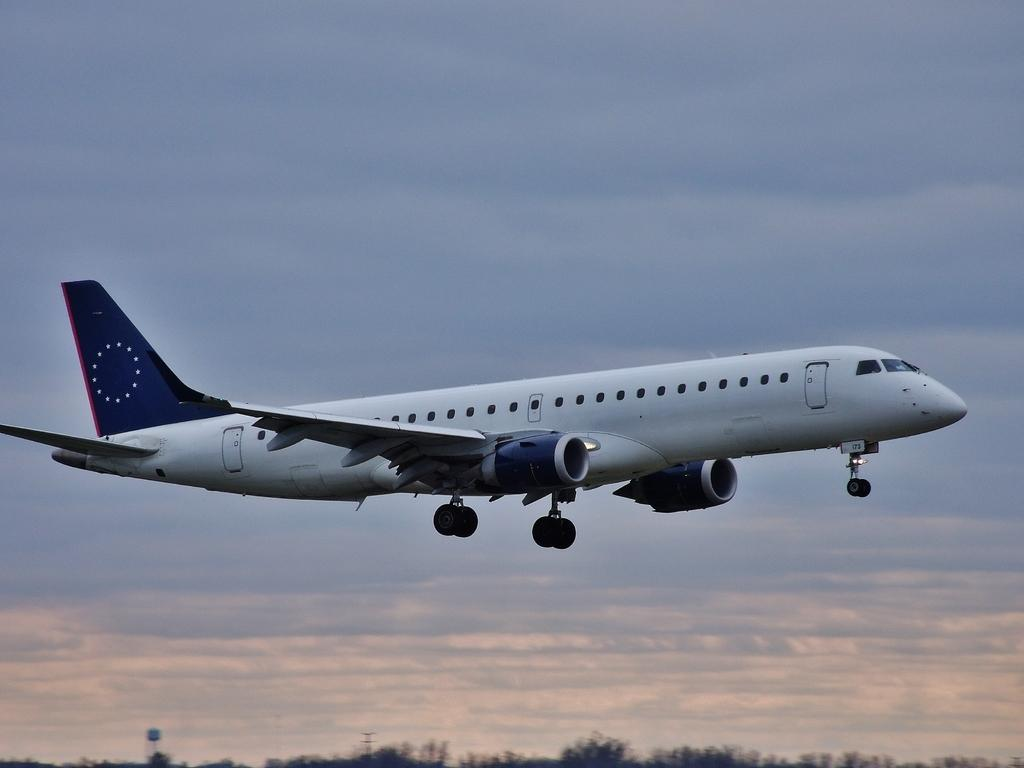What is the main subject of the image? The main subject of the image is an aeroplane. What is the aeroplane doing in the image? The aeroplane is flying in the sky. What can be seen at the bottom of the image? There are trees and poles at the bottom of the image. What type of tool does the carpenter use to communicate with the aeroplane in the image? There is no carpenter or tool present in the image, and the aeroplane is not communicating with anyone. What is the voice of the bag in the image? There is no bag or voice present in the image. 